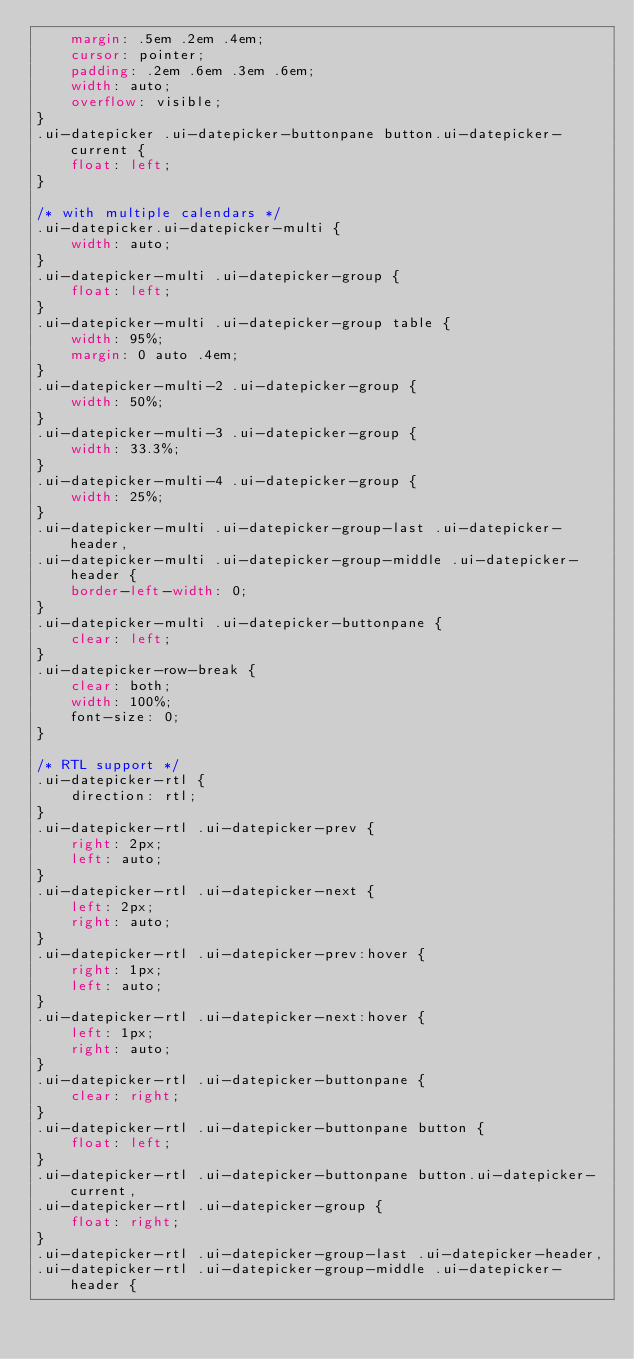<code> <loc_0><loc_0><loc_500><loc_500><_CSS_>	margin: .5em .2em .4em;
	cursor: pointer;
	padding: .2em .6em .3em .6em;
	width: auto;
	overflow: visible;
}
.ui-datepicker .ui-datepicker-buttonpane button.ui-datepicker-current {
	float: left;
}

/* with multiple calendars */
.ui-datepicker.ui-datepicker-multi {
	width: auto;
}
.ui-datepicker-multi .ui-datepicker-group {
	float: left;
}
.ui-datepicker-multi .ui-datepicker-group table {
	width: 95%;
	margin: 0 auto .4em;
}
.ui-datepicker-multi-2 .ui-datepicker-group {
	width: 50%;
}
.ui-datepicker-multi-3 .ui-datepicker-group {
	width: 33.3%;
}
.ui-datepicker-multi-4 .ui-datepicker-group {
	width: 25%;
}
.ui-datepicker-multi .ui-datepicker-group-last .ui-datepicker-header,
.ui-datepicker-multi .ui-datepicker-group-middle .ui-datepicker-header {
	border-left-width: 0;
}
.ui-datepicker-multi .ui-datepicker-buttonpane {
	clear: left;
}
.ui-datepicker-row-break {
	clear: both;
	width: 100%;
	font-size: 0;
}

/* RTL support */
.ui-datepicker-rtl {
	direction: rtl;
}
.ui-datepicker-rtl .ui-datepicker-prev {
	right: 2px;
	left: auto;
}
.ui-datepicker-rtl .ui-datepicker-next {
	left: 2px;
	right: auto;
}
.ui-datepicker-rtl .ui-datepicker-prev:hover {
	right: 1px;
	left: auto;
}
.ui-datepicker-rtl .ui-datepicker-next:hover {
	left: 1px;
	right: auto;
}
.ui-datepicker-rtl .ui-datepicker-buttonpane {
	clear: right;
}
.ui-datepicker-rtl .ui-datepicker-buttonpane button {
	float: left;
}
.ui-datepicker-rtl .ui-datepicker-buttonpane button.ui-datepicker-current,
.ui-datepicker-rtl .ui-datepicker-group {
	float: right;
}
.ui-datepicker-rtl .ui-datepicker-group-last .ui-datepicker-header,
.ui-datepicker-rtl .ui-datepicker-group-middle .ui-datepicker-header {</code> 